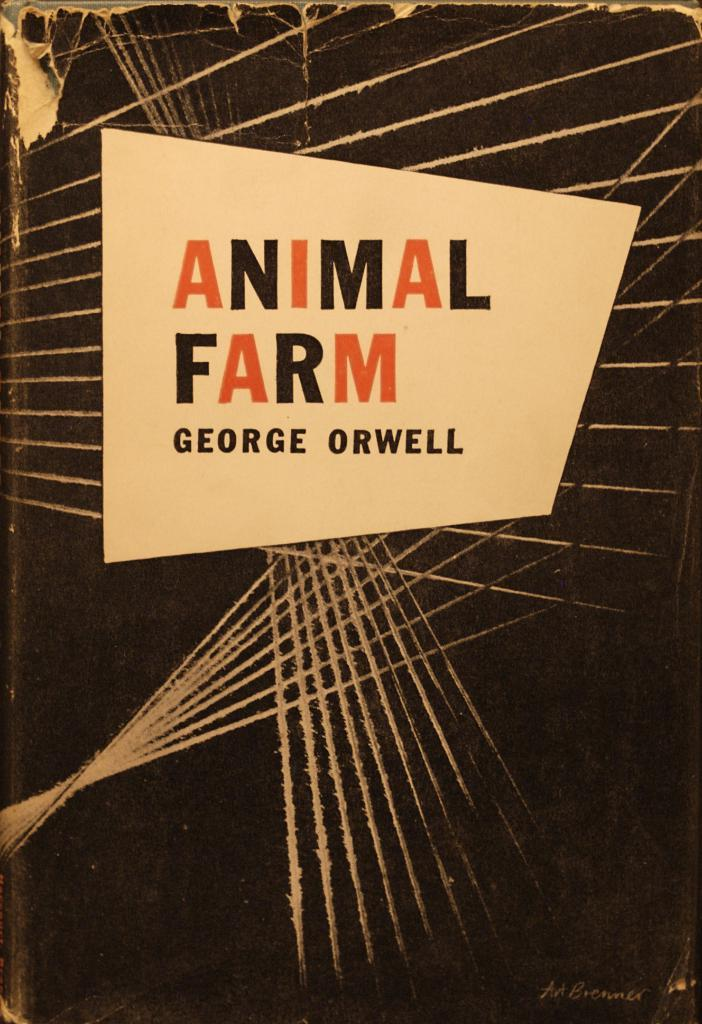<image>
Create a compact narrative representing the image presented. An old book called Animal farm by George Orwell 